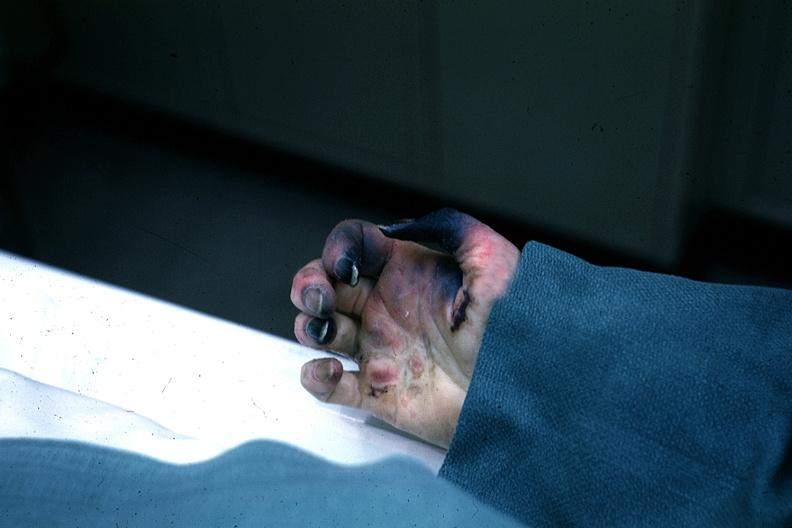s digits said to be due to embolism?
Answer the question using a single word or phrase. No 